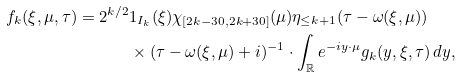Convert formula to latex. <formula><loc_0><loc_0><loc_500><loc_500>f _ { k } ( \xi , \mu , \tau ) = 2 ^ { k / 2 } & 1 _ { I _ { k } } ( \xi ) \chi _ { [ 2 k - 3 0 , 2 k + 3 0 ] } ( \mu ) \eta _ { \leq k + 1 } ( \tau - \omega ( \xi , \mu ) ) \\ & \times ( \tau - \omega ( \xi , \mu ) + i ) ^ { - 1 } \cdot \int _ { \mathbb { R } } e ^ { - i y \cdot \mu } g _ { k } ( y , \xi , \tau ) \, d y ,</formula> 